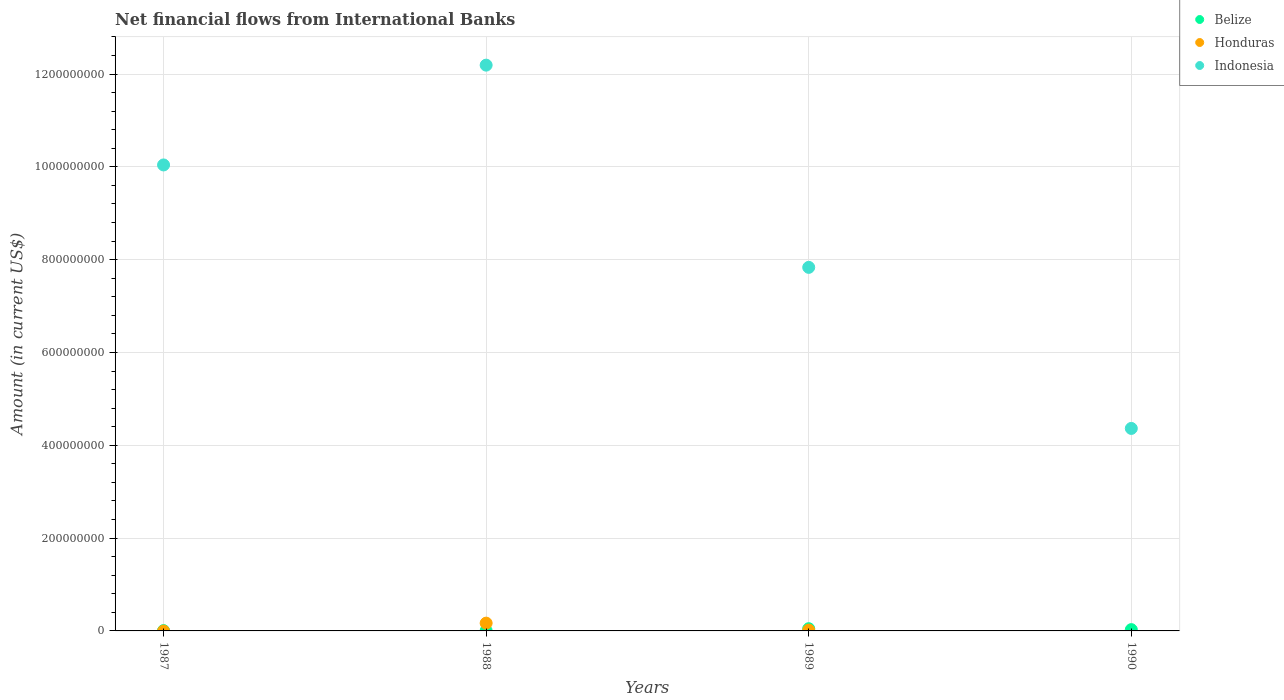What is the net financial aid flows in Honduras in 1990?
Offer a very short reply. 0. Across all years, what is the maximum net financial aid flows in Honduras?
Offer a very short reply. 1.68e+07. Across all years, what is the minimum net financial aid flows in Belize?
Ensure brevity in your answer.  5.10e+05. What is the total net financial aid flows in Indonesia in the graph?
Keep it short and to the point. 3.44e+09. What is the difference between the net financial aid flows in Indonesia in 1988 and that in 1990?
Your response must be concise. 7.83e+08. What is the difference between the net financial aid flows in Indonesia in 1989 and the net financial aid flows in Honduras in 1987?
Make the answer very short. 7.83e+08. What is the average net financial aid flows in Indonesia per year?
Ensure brevity in your answer.  8.61e+08. In the year 1987, what is the difference between the net financial aid flows in Belize and net financial aid flows in Indonesia?
Give a very brief answer. -1.00e+09. In how many years, is the net financial aid flows in Belize greater than 680000000 US$?
Give a very brief answer. 0. What is the ratio of the net financial aid flows in Belize in 1988 to that in 1989?
Make the answer very short. 0.11. Is the difference between the net financial aid flows in Belize in 1989 and 1990 greater than the difference between the net financial aid flows in Indonesia in 1989 and 1990?
Give a very brief answer. No. What is the difference between the highest and the second highest net financial aid flows in Belize?
Your response must be concise. 1.98e+06. What is the difference between the highest and the lowest net financial aid flows in Indonesia?
Your answer should be very brief. 7.83e+08. In how many years, is the net financial aid flows in Belize greater than the average net financial aid flows in Belize taken over all years?
Keep it short and to the point. 2. Is the sum of the net financial aid flows in Belize in 1988 and 1990 greater than the maximum net financial aid flows in Honduras across all years?
Make the answer very short. No. Is the net financial aid flows in Honduras strictly greater than the net financial aid flows in Indonesia over the years?
Provide a short and direct response. No. Does the graph contain any zero values?
Provide a succinct answer. Yes. Where does the legend appear in the graph?
Keep it short and to the point. Top right. How many legend labels are there?
Your answer should be compact. 3. What is the title of the graph?
Offer a very short reply. Net financial flows from International Banks. Does "Australia" appear as one of the legend labels in the graph?
Your response must be concise. No. What is the label or title of the Y-axis?
Give a very brief answer. Amount (in current US$). What is the Amount (in current US$) in Belize in 1987?
Provide a succinct answer. 6.65e+05. What is the Amount (in current US$) in Indonesia in 1987?
Make the answer very short. 1.00e+09. What is the Amount (in current US$) in Belize in 1988?
Ensure brevity in your answer.  5.10e+05. What is the Amount (in current US$) of Honduras in 1988?
Give a very brief answer. 1.68e+07. What is the Amount (in current US$) of Indonesia in 1988?
Provide a short and direct response. 1.22e+09. What is the Amount (in current US$) of Belize in 1989?
Give a very brief answer. 4.76e+06. What is the Amount (in current US$) of Honduras in 1989?
Your response must be concise. 1.78e+06. What is the Amount (in current US$) of Indonesia in 1989?
Make the answer very short. 7.83e+08. What is the Amount (in current US$) in Belize in 1990?
Keep it short and to the point. 2.78e+06. What is the Amount (in current US$) of Indonesia in 1990?
Offer a terse response. 4.36e+08. Across all years, what is the maximum Amount (in current US$) in Belize?
Your answer should be compact. 4.76e+06. Across all years, what is the maximum Amount (in current US$) of Honduras?
Ensure brevity in your answer.  1.68e+07. Across all years, what is the maximum Amount (in current US$) of Indonesia?
Keep it short and to the point. 1.22e+09. Across all years, what is the minimum Amount (in current US$) in Belize?
Offer a terse response. 5.10e+05. Across all years, what is the minimum Amount (in current US$) of Indonesia?
Your answer should be very brief. 4.36e+08. What is the total Amount (in current US$) in Belize in the graph?
Offer a very short reply. 8.72e+06. What is the total Amount (in current US$) of Honduras in the graph?
Offer a very short reply. 1.86e+07. What is the total Amount (in current US$) of Indonesia in the graph?
Give a very brief answer. 3.44e+09. What is the difference between the Amount (in current US$) of Belize in 1987 and that in 1988?
Make the answer very short. 1.55e+05. What is the difference between the Amount (in current US$) in Indonesia in 1987 and that in 1988?
Give a very brief answer. -2.15e+08. What is the difference between the Amount (in current US$) in Belize in 1987 and that in 1989?
Your answer should be compact. -4.10e+06. What is the difference between the Amount (in current US$) in Indonesia in 1987 and that in 1989?
Offer a very short reply. 2.21e+08. What is the difference between the Amount (in current US$) in Belize in 1987 and that in 1990?
Your answer should be very brief. -2.12e+06. What is the difference between the Amount (in current US$) in Indonesia in 1987 and that in 1990?
Provide a succinct answer. 5.68e+08. What is the difference between the Amount (in current US$) in Belize in 1988 and that in 1989?
Your response must be concise. -4.25e+06. What is the difference between the Amount (in current US$) of Honduras in 1988 and that in 1989?
Provide a succinct answer. 1.50e+07. What is the difference between the Amount (in current US$) of Indonesia in 1988 and that in 1989?
Provide a short and direct response. 4.36e+08. What is the difference between the Amount (in current US$) of Belize in 1988 and that in 1990?
Offer a terse response. -2.28e+06. What is the difference between the Amount (in current US$) in Indonesia in 1988 and that in 1990?
Offer a terse response. 7.83e+08. What is the difference between the Amount (in current US$) of Belize in 1989 and that in 1990?
Your answer should be very brief. 1.98e+06. What is the difference between the Amount (in current US$) of Indonesia in 1989 and that in 1990?
Provide a succinct answer. 3.47e+08. What is the difference between the Amount (in current US$) in Belize in 1987 and the Amount (in current US$) in Honduras in 1988?
Make the answer very short. -1.61e+07. What is the difference between the Amount (in current US$) of Belize in 1987 and the Amount (in current US$) of Indonesia in 1988?
Provide a short and direct response. -1.22e+09. What is the difference between the Amount (in current US$) of Belize in 1987 and the Amount (in current US$) of Honduras in 1989?
Your answer should be compact. -1.11e+06. What is the difference between the Amount (in current US$) in Belize in 1987 and the Amount (in current US$) in Indonesia in 1989?
Offer a very short reply. -7.83e+08. What is the difference between the Amount (in current US$) of Belize in 1987 and the Amount (in current US$) of Indonesia in 1990?
Provide a succinct answer. -4.36e+08. What is the difference between the Amount (in current US$) of Belize in 1988 and the Amount (in current US$) of Honduras in 1989?
Make the answer very short. -1.27e+06. What is the difference between the Amount (in current US$) in Belize in 1988 and the Amount (in current US$) in Indonesia in 1989?
Keep it short and to the point. -7.83e+08. What is the difference between the Amount (in current US$) of Honduras in 1988 and the Amount (in current US$) of Indonesia in 1989?
Offer a terse response. -7.67e+08. What is the difference between the Amount (in current US$) in Belize in 1988 and the Amount (in current US$) in Indonesia in 1990?
Ensure brevity in your answer.  -4.36e+08. What is the difference between the Amount (in current US$) in Honduras in 1988 and the Amount (in current US$) in Indonesia in 1990?
Make the answer very short. -4.20e+08. What is the difference between the Amount (in current US$) in Belize in 1989 and the Amount (in current US$) in Indonesia in 1990?
Offer a very short reply. -4.32e+08. What is the difference between the Amount (in current US$) in Honduras in 1989 and the Amount (in current US$) in Indonesia in 1990?
Make the answer very short. -4.35e+08. What is the average Amount (in current US$) of Belize per year?
Provide a succinct answer. 2.18e+06. What is the average Amount (in current US$) of Honduras per year?
Give a very brief answer. 4.64e+06. What is the average Amount (in current US$) of Indonesia per year?
Provide a succinct answer. 8.61e+08. In the year 1987, what is the difference between the Amount (in current US$) of Belize and Amount (in current US$) of Indonesia?
Provide a short and direct response. -1.00e+09. In the year 1988, what is the difference between the Amount (in current US$) in Belize and Amount (in current US$) in Honduras?
Make the answer very short. -1.63e+07. In the year 1988, what is the difference between the Amount (in current US$) of Belize and Amount (in current US$) of Indonesia?
Keep it short and to the point. -1.22e+09. In the year 1988, what is the difference between the Amount (in current US$) of Honduras and Amount (in current US$) of Indonesia?
Make the answer very short. -1.20e+09. In the year 1989, what is the difference between the Amount (in current US$) of Belize and Amount (in current US$) of Honduras?
Give a very brief answer. 2.99e+06. In the year 1989, what is the difference between the Amount (in current US$) of Belize and Amount (in current US$) of Indonesia?
Ensure brevity in your answer.  -7.79e+08. In the year 1989, what is the difference between the Amount (in current US$) of Honduras and Amount (in current US$) of Indonesia?
Provide a short and direct response. -7.82e+08. In the year 1990, what is the difference between the Amount (in current US$) in Belize and Amount (in current US$) in Indonesia?
Ensure brevity in your answer.  -4.34e+08. What is the ratio of the Amount (in current US$) in Belize in 1987 to that in 1988?
Offer a terse response. 1.3. What is the ratio of the Amount (in current US$) of Indonesia in 1987 to that in 1988?
Provide a succinct answer. 0.82. What is the ratio of the Amount (in current US$) in Belize in 1987 to that in 1989?
Offer a terse response. 0.14. What is the ratio of the Amount (in current US$) of Indonesia in 1987 to that in 1989?
Provide a succinct answer. 1.28. What is the ratio of the Amount (in current US$) of Belize in 1987 to that in 1990?
Give a very brief answer. 0.24. What is the ratio of the Amount (in current US$) of Indonesia in 1987 to that in 1990?
Provide a succinct answer. 2.3. What is the ratio of the Amount (in current US$) of Belize in 1988 to that in 1989?
Your answer should be very brief. 0.11. What is the ratio of the Amount (in current US$) in Honduras in 1988 to that in 1989?
Provide a short and direct response. 9.45. What is the ratio of the Amount (in current US$) in Indonesia in 1988 to that in 1989?
Keep it short and to the point. 1.56. What is the ratio of the Amount (in current US$) in Belize in 1988 to that in 1990?
Offer a very short reply. 0.18. What is the ratio of the Amount (in current US$) of Indonesia in 1988 to that in 1990?
Make the answer very short. 2.79. What is the ratio of the Amount (in current US$) of Belize in 1989 to that in 1990?
Your answer should be very brief. 1.71. What is the ratio of the Amount (in current US$) of Indonesia in 1989 to that in 1990?
Offer a terse response. 1.8. What is the difference between the highest and the second highest Amount (in current US$) in Belize?
Offer a terse response. 1.98e+06. What is the difference between the highest and the second highest Amount (in current US$) of Indonesia?
Provide a short and direct response. 2.15e+08. What is the difference between the highest and the lowest Amount (in current US$) in Belize?
Keep it short and to the point. 4.25e+06. What is the difference between the highest and the lowest Amount (in current US$) of Honduras?
Offer a terse response. 1.68e+07. What is the difference between the highest and the lowest Amount (in current US$) in Indonesia?
Make the answer very short. 7.83e+08. 